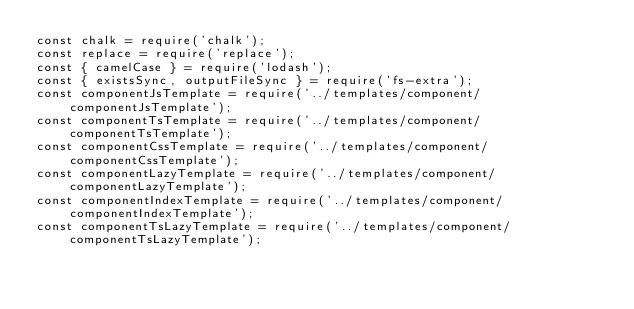<code> <loc_0><loc_0><loc_500><loc_500><_JavaScript_>const chalk = require('chalk');
const replace = require('replace');
const { camelCase } = require('lodash');
const { existsSync, outputFileSync } = require('fs-extra');
const componentJsTemplate = require('../templates/component/componentJsTemplate');
const componentTsTemplate = require('../templates/component/componentTsTemplate');
const componentCssTemplate = require('../templates/component/componentCssTemplate');
const componentLazyTemplate = require('../templates/component/componentLazyTemplate');
const componentIndexTemplate = require('../templates/component/componentIndexTemplate');
const componentTsLazyTemplate = require('../templates/component/componentTsLazyTemplate');</code> 